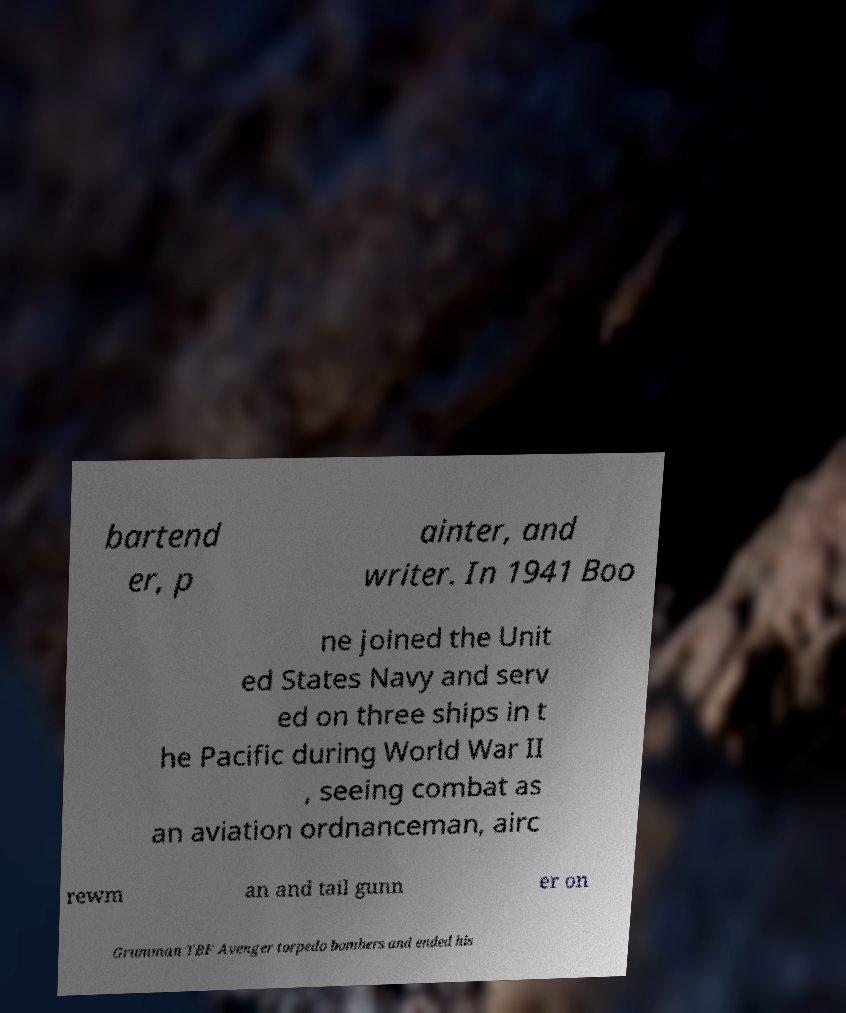Could you extract and type out the text from this image? bartend er, p ainter, and writer. In 1941 Boo ne joined the Unit ed States Navy and serv ed on three ships in t he Pacific during World War II , seeing combat as an aviation ordnanceman, airc rewm an and tail gunn er on Grumman TBF Avenger torpedo bombers and ended his 